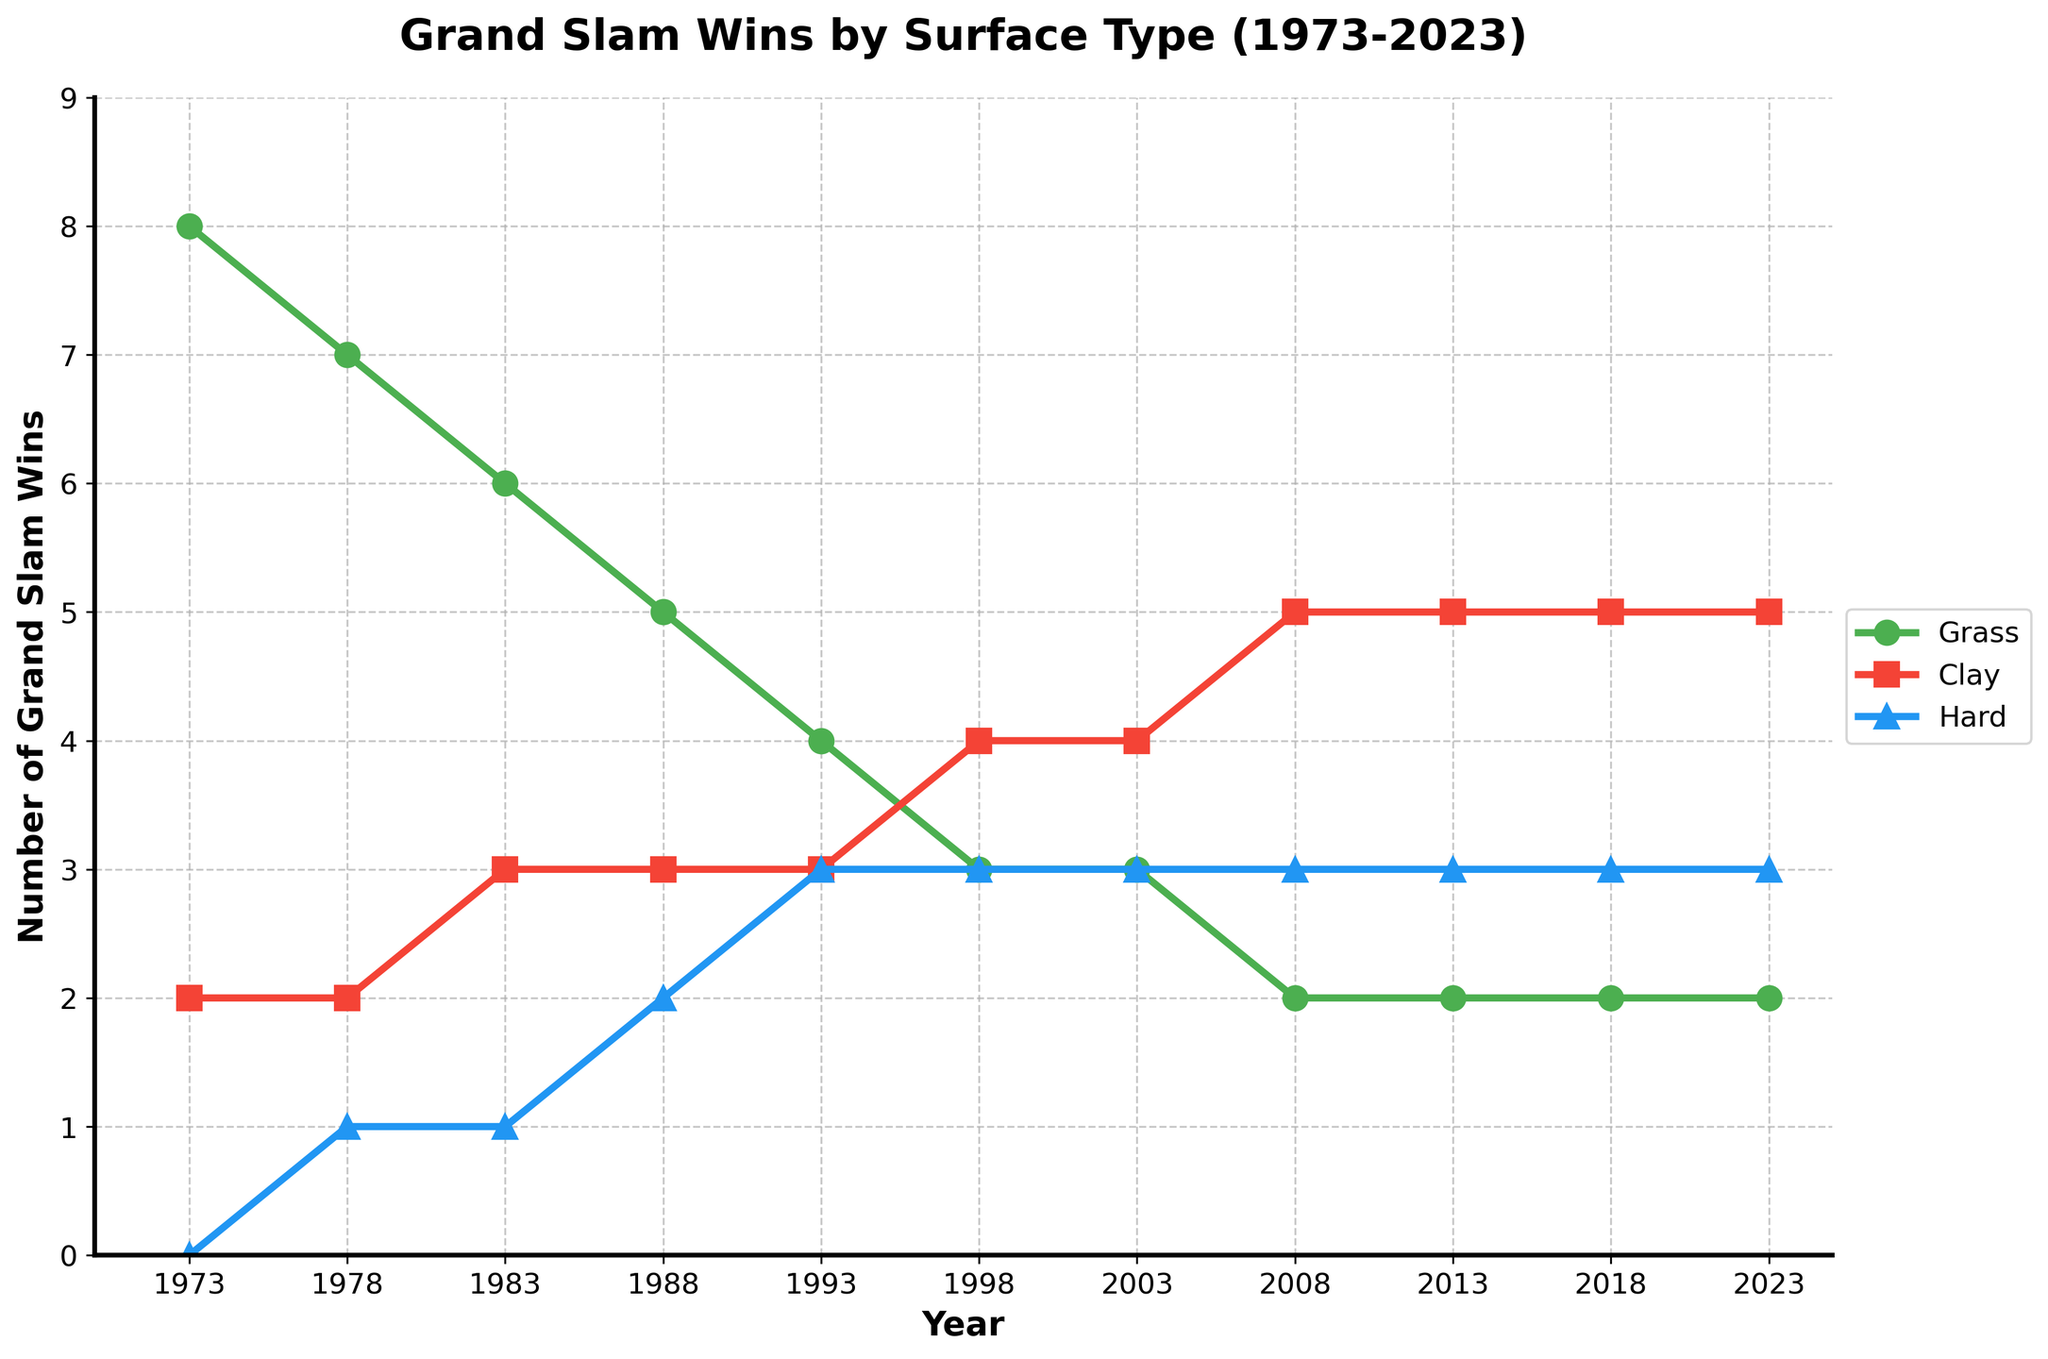What is the trend in Grand Slam wins on grass courts from 1973 to 2023? The number of Grand Slam wins on grass courts shows a decreasing trend over the years. In 1973, there were 8 wins, which gradually decreased to 2 wins by 2023.
Answer: Decreasing In which year did the number of Grand Slam wins on clay courts first surpass the wins on grass courts? By examining the chart, one can see that the number of clay court wins first exceeds grass court wins in the year 1998, where clay court wins were 4 and grass court wins were 3.
Answer: 1998 What is the difference in the number of Grand Slam wins between grass and hard courts in 1988? In 1988, the number of wins on grass courts was 5, and the number on hard courts was 2. The difference is \( 5 - 2 \).
Answer: 3 During which decade did the number of Grand Slam wins on clay courts remain unchanged? The number of Grand Slam wins on clay courts remained constant at 5 during the decade from 2008 to 2023.
Answer: 2010s Which surface type exhibits the least change in the number of Grand Slam wins over the 50 years? By analyzing the fluctuations on the chart, it shows that the number of wins on hard courts remains quite constant, oscillating between 0 to 3 wins without sharp changes.
Answer: Hard courts How many Grand Slam wins on grass courts were recorded by 2003? Summing up the wins on grass courts from 1973 to 2003: \( 8 + 7 + 6 + 5 + 4 + 3 = 33 \).
Answer: 33 What is the average number of Grand Slam wins on clay courts from 1998 to 2023? Sum up the wins from 1998 to 2023: \( 4 + 4 + 5 + 5 + 5 = 23 \), divide by the number of years: \( 23 / 5 = 4.6 \).
Answer: 4.6 Which surface had the highest number of Grand Slam wins in 1973? The chart shows 8 wins on grass courts in 1973, which is higher compared to 2 on clay and 0 on hard courts.
Answer: Grass In which year did hard court Grand Slam wins reach 3 for the first time? Referring to the chart, hard court wins reached 3 for the first time in the year 1993.
Answer: 1993 Compare the changes in Grand Slam wins on clay and hard courts from 1973 to 2023. From 1973 to 2023, clay court wins increased from 2 to 5, while hard court wins increased from 0 to 3.
Answer: Clay: +3, Hard: +3 